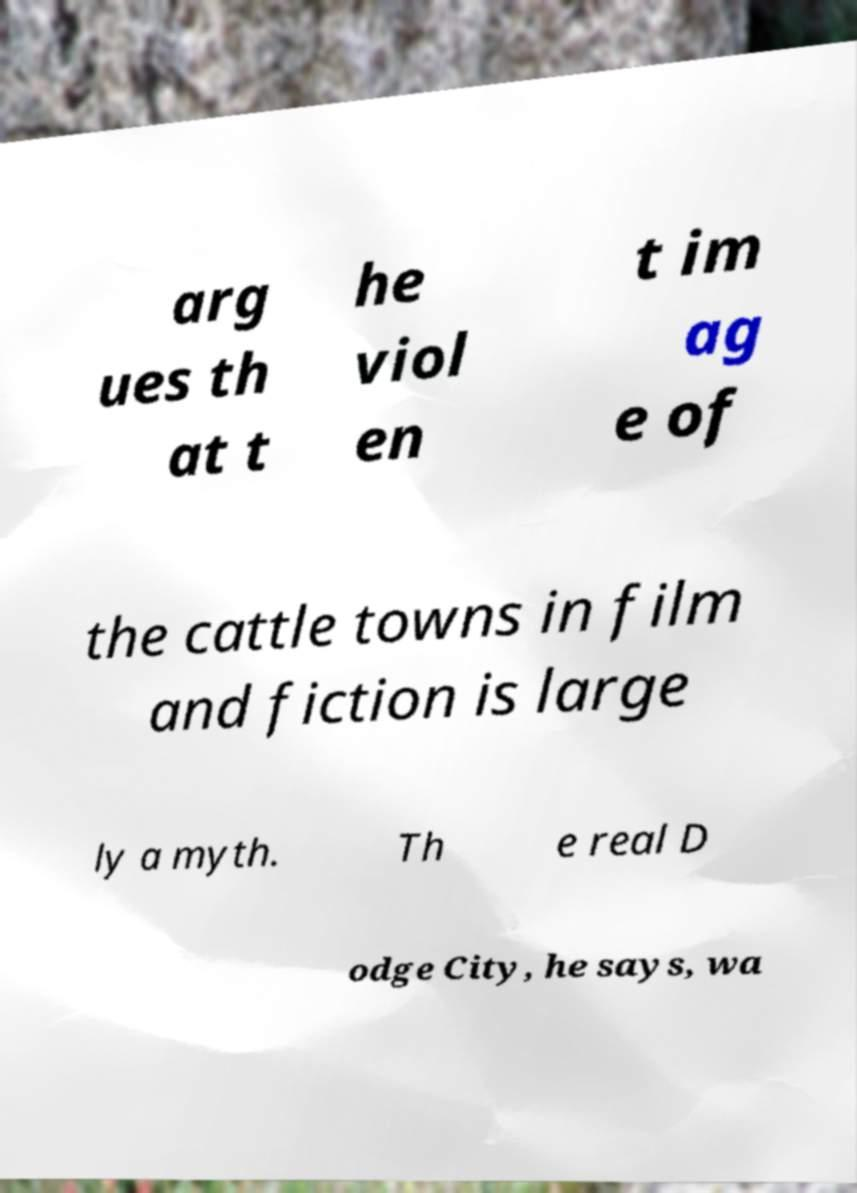Please read and relay the text visible in this image. What does it say? arg ues th at t he viol en t im ag e of the cattle towns in film and fiction is large ly a myth. Th e real D odge City, he says, wa 